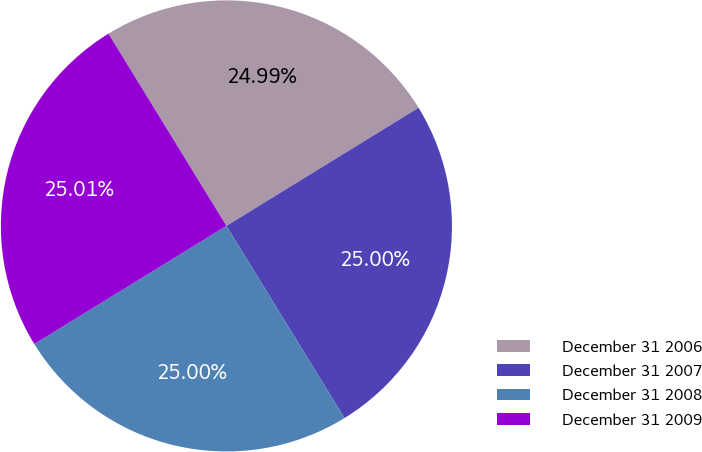Convert chart to OTSL. <chart><loc_0><loc_0><loc_500><loc_500><pie_chart><fcel>December 31 2006<fcel>December 31 2007<fcel>December 31 2008<fcel>December 31 2009<nl><fcel>24.99%<fcel>25.0%<fcel>25.0%<fcel>25.01%<nl></chart> 